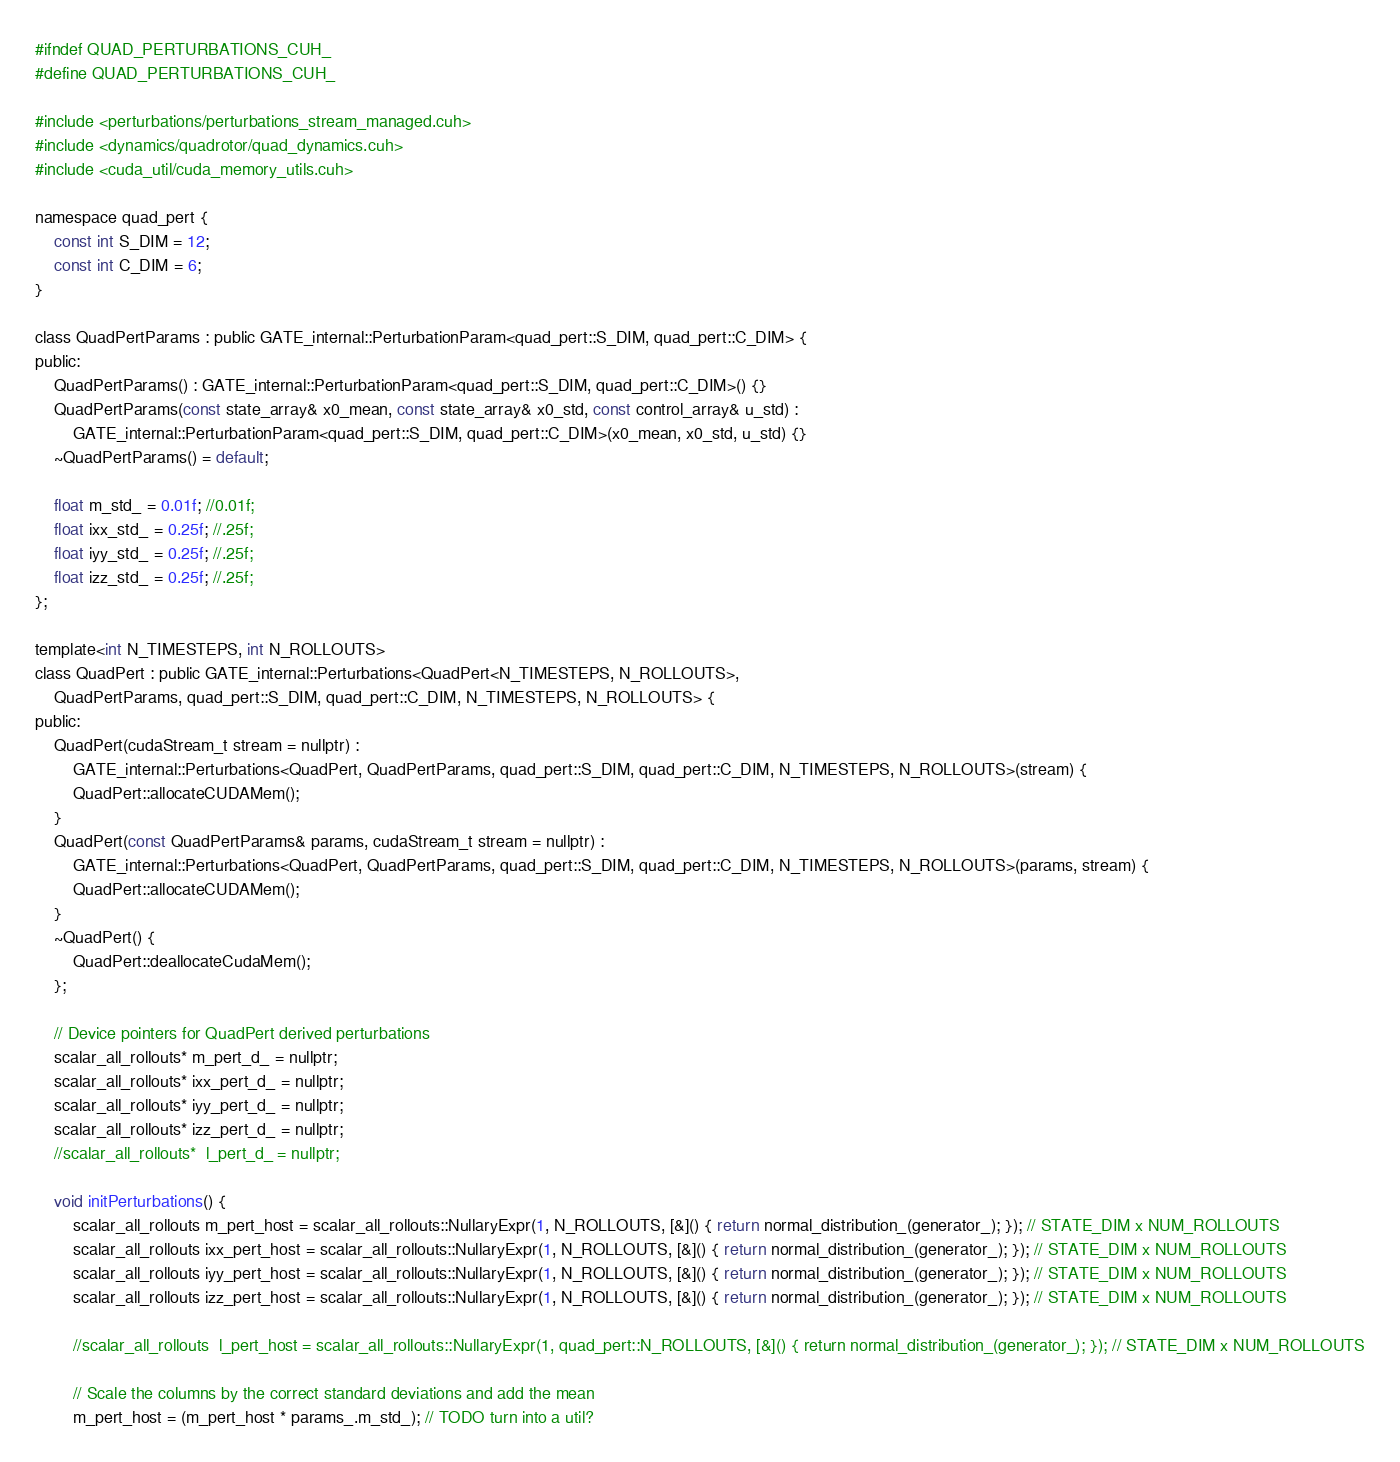Convert code to text. <code><loc_0><loc_0><loc_500><loc_500><_Cuda_>#ifndef QUAD_PERTURBATIONS_CUH_
#define QUAD_PERTURBATIONS_CUH_

#include <perturbations/perturbations_stream_managed.cuh>
#include <dynamics/quadrotor/quad_dynamics.cuh>
#include <cuda_util/cuda_memory_utils.cuh>

namespace quad_pert {
	const int S_DIM = 12;
	const int C_DIM = 6;
}

class QuadPertParams : public GATE_internal::PerturbationParam<quad_pert::S_DIM, quad_pert::C_DIM> {
public:
	QuadPertParams() : GATE_internal::PerturbationParam<quad_pert::S_DIM, quad_pert::C_DIM>() {}
	QuadPertParams(const state_array& x0_mean, const state_array& x0_std, const control_array& u_std) :
		GATE_internal::PerturbationParam<quad_pert::S_DIM, quad_pert::C_DIM>(x0_mean, x0_std, u_std) {}
	~QuadPertParams() = default;

	float m_std_ = 0.01f; //0.01f;
	float ixx_std_ = 0.25f; //.25f;
	float iyy_std_ = 0.25f; //.25f;
	float izz_std_ = 0.25f; //.25f;
};

template<int N_TIMESTEPS, int N_ROLLOUTS>
class QuadPert : public GATE_internal::Perturbations<QuadPert<N_TIMESTEPS, N_ROLLOUTS>,
	QuadPertParams, quad_pert::S_DIM, quad_pert::C_DIM, N_TIMESTEPS, N_ROLLOUTS> {
public:
	QuadPert(cudaStream_t stream = nullptr) :
		GATE_internal::Perturbations<QuadPert, QuadPertParams, quad_pert::S_DIM, quad_pert::C_DIM, N_TIMESTEPS, N_ROLLOUTS>(stream) {
		QuadPert::allocateCUDAMem();
	}
	QuadPert(const QuadPertParams& params, cudaStream_t stream = nullptr) :
		GATE_internal::Perturbations<QuadPert, QuadPertParams, quad_pert::S_DIM, quad_pert::C_DIM, N_TIMESTEPS, N_ROLLOUTS>(params, stream) {
		QuadPert::allocateCUDAMem();
	}
	~QuadPert() {
		QuadPert::deallocateCudaMem();
	};

	// Device pointers for QuadPert derived perturbations
	scalar_all_rollouts* m_pert_d_ = nullptr;
	scalar_all_rollouts* ixx_pert_d_ = nullptr;
	scalar_all_rollouts* iyy_pert_d_ = nullptr;
	scalar_all_rollouts* izz_pert_d_ = nullptr;
	//scalar_all_rollouts*  l_pert_d_ = nullptr;

	void initPerturbations() {
		scalar_all_rollouts m_pert_host = scalar_all_rollouts::NullaryExpr(1, N_ROLLOUTS, [&]() { return normal_distribution_(generator_); }); // STATE_DIM x NUM_ROLLOUTS
		scalar_all_rollouts ixx_pert_host = scalar_all_rollouts::NullaryExpr(1, N_ROLLOUTS, [&]() { return normal_distribution_(generator_); }); // STATE_DIM x NUM_ROLLOUTS
		scalar_all_rollouts iyy_pert_host = scalar_all_rollouts::NullaryExpr(1, N_ROLLOUTS, [&]() { return normal_distribution_(generator_); }); // STATE_DIM x NUM_ROLLOUTS
		scalar_all_rollouts izz_pert_host = scalar_all_rollouts::NullaryExpr(1, N_ROLLOUTS, [&]() { return normal_distribution_(generator_); }); // STATE_DIM x NUM_ROLLOUTS

		//scalar_all_rollouts  l_pert_host = scalar_all_rollouts::NullaryExpr(1, quad_pert::N_ROLLOUTS, [&]() { return normal_distribution_(generator_); }); // STATE_DIM x NUM_ROLLOUTS

		// Scale the columns by the correct standard deviations and add the mean
		m_pert_host = (m_pert_host * params_.m_std_); // TODO turn into a util?</code> 